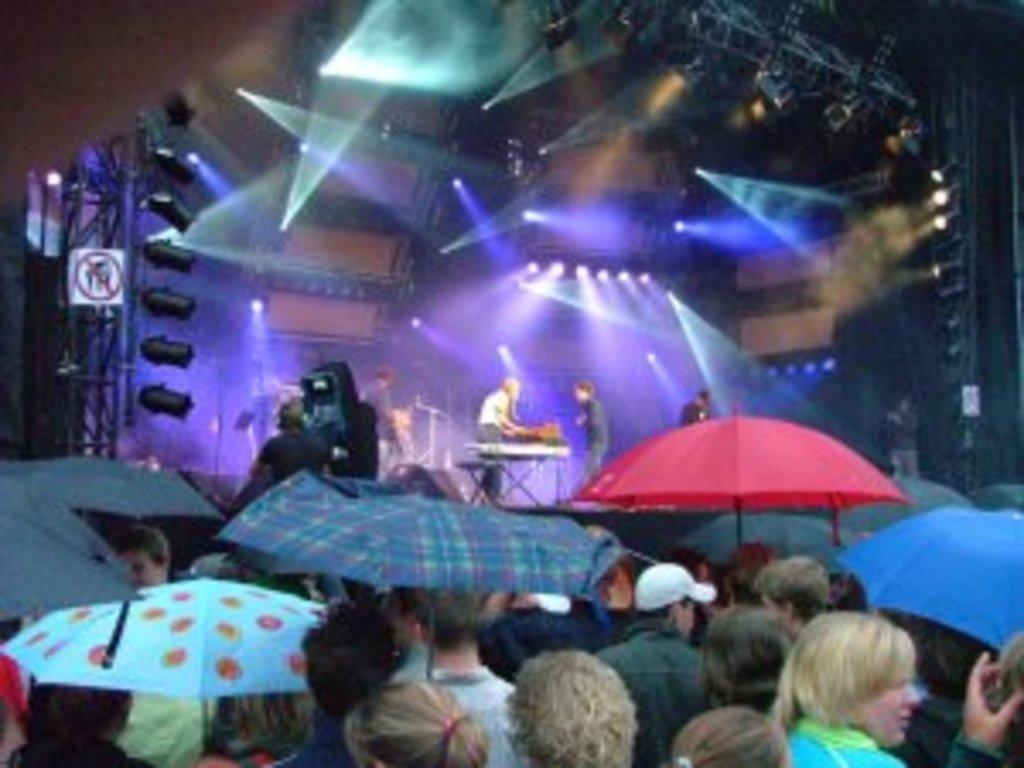Describe this image in one or two sentences. In this image we can see some group of persons standing on the ground holding umbrellas in their hands and in the background of the image there are some persons standing on the stage and playing some musical instruments and we can see some lights. 